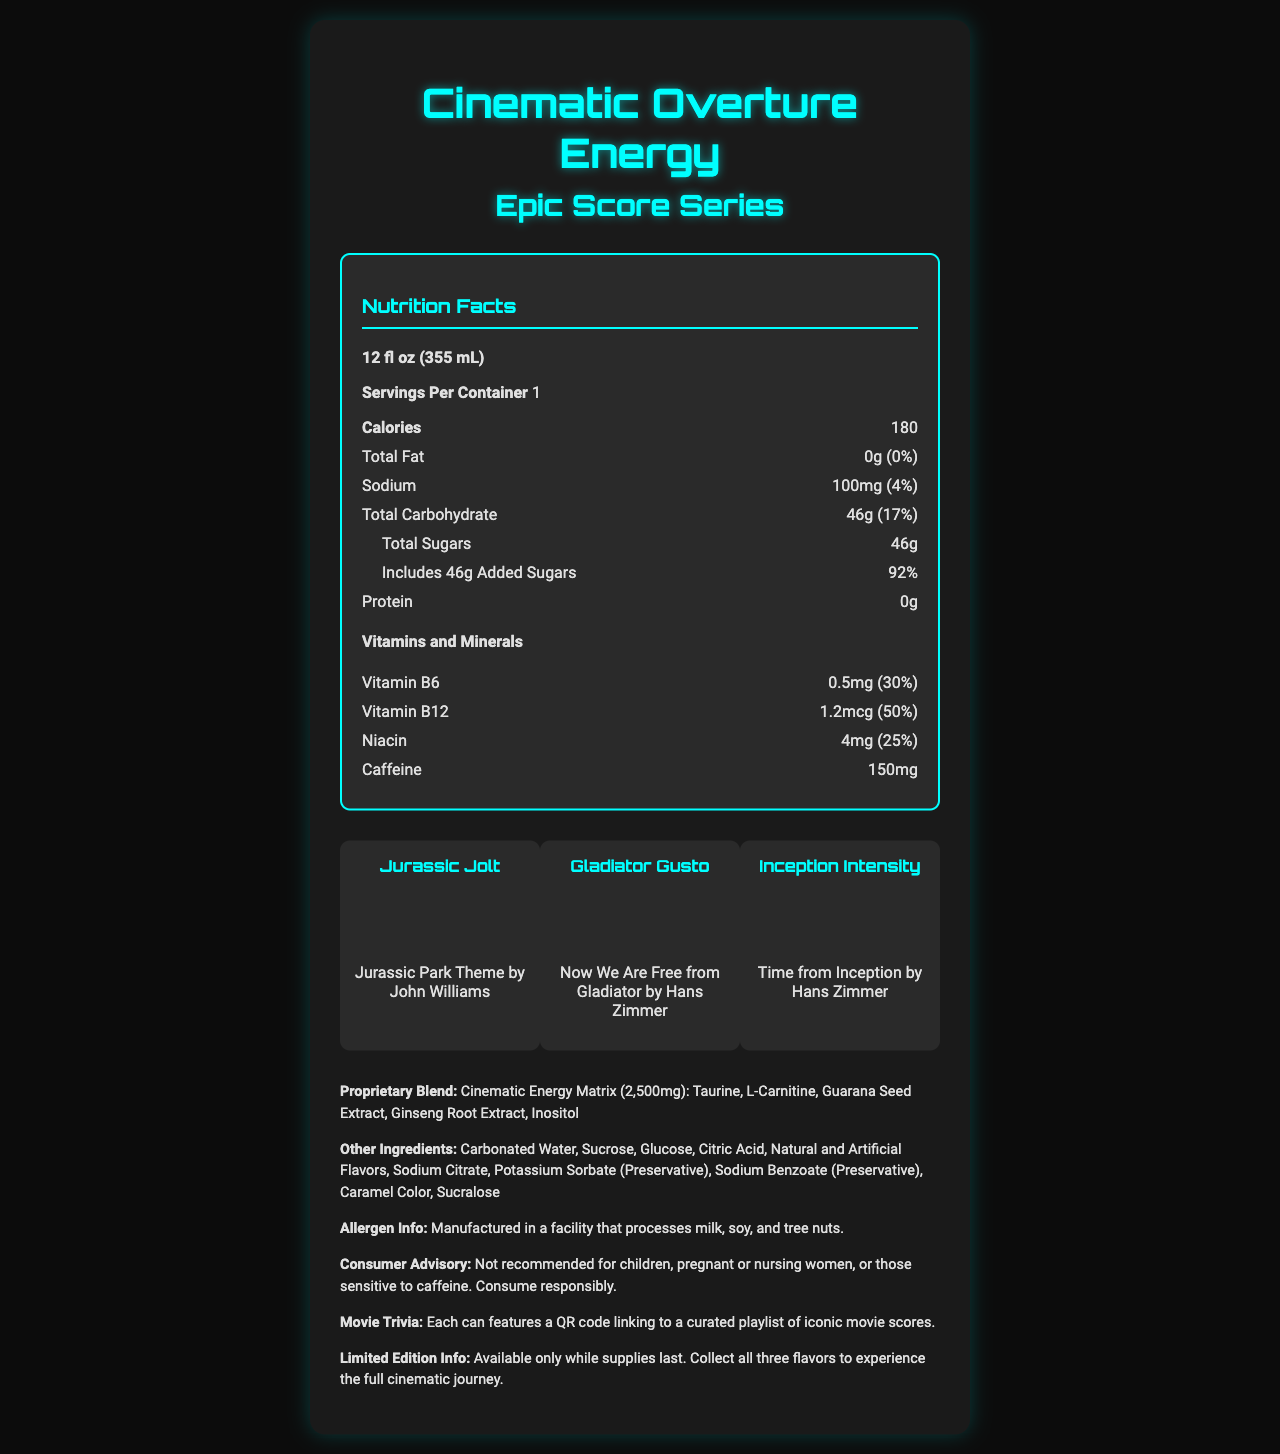Who is the musician that inspired the Jurassic Jolt flavor? The Jurassic Jolt flavor is inspired by the Jurassic Park theme by John Williams, as mentioned in the document.
Answer: John Williams What is the daily value percentage of Vitamin B12? The daily value percentage of Vitamin B12 shown in the document is 50%.
Answer: 50% How much caffeine is in one serving? The document lists 150mg of caffeine per serving.
Answer: 150mg What is the total sugar content in the energy drink? The total sugars listed in the document are 46g.
Answer: 46g Summarize the main idea of the document. The document is rich in details about the energy drink collection inspired by epic movie scores, providing detailed nutritional information, ingredients, and additional product descriptions.
Answer: The document provides the nutrition facts for "Cinematic Overture Energy" from the "Epic Score Series" collection. It details the flavors inspired by movie scores, the nutritional information, proprietary blend, other ingredients, allergen info, consumer advisory, and limited edition information. The calorie count of the energy drink is: The document specifies that each serving contains 180 calories.
Answer: 180 calories Which flavor is inspired by "Now We Are Free" from Gladiator? A. Jurassic Jolt B. Gladiator Gusto C. Inception Intensity Gladiator Gusto is the flavor inspired by "Now We Are Free" from Gladiator, as mentioned in the document.
Answer: B. Gladiator Gusto What is the color of the Inception Intensity flavor? A. Amber B. Ruby Red C. Electric Blue The Inception Intensity flavor is listed as Electric Blue in the document.
Answer: C. Electric Blue Does the document mention any specific dietary restrictions or consumer advisories? The document advises that the drink is not recommended for children, pregnant or nursing women, or those sensitive to caffeine. Consume responsibly.
Answer: Yes How many servings are there per container? The document states that there is one serving per container.
Answer: 1 Can I find out the manufacturing location of the energy drink from this document? The document does not provide information about the manufacturing location.
Answer: Cannot be determined What is the proprietary blend called? The document names the proprietary blend as the Cinematic Energy Matrix.
Answer: Cinematic Energy Matrix Which vitamins are included in the energy drink? The vitamins listed in the document include Vitamin B6, Vitamin B12, and Niacin.
Answer: Vitamin B6, Vitamin B12, Niacin Is the product part of a limited edition series? The document states that the product is part of a limited edition collection, available only while supplies last.
Answer: Yes What additional feature does each can have relating to movie scores? The document mentions that each can has a QR code that links to a curated playlist of iconic movie scores.
Answer: Each can features a QR code linking to a curated playlist of iconic movie scores. Which company produces the energy drink? The document does not specify the company that produces the energy drink.
Answer: Not enough information What is the total carbohydrate content and its daily value percentage? The document lists the total carbohydrate content as 46g with a daily value percentage of 17%.
Answer: 46g, 17% What additional colors are used in the flavors besides Electric Blue? A. Amber B. Ruby Red C. Both Amber and Ruby Red Amber is used for Jurassic Jolt and Ruby Red is used for Gladiator Gusto, as mentioned in the document.
Answer: C. Both Amber and Ruby Red 